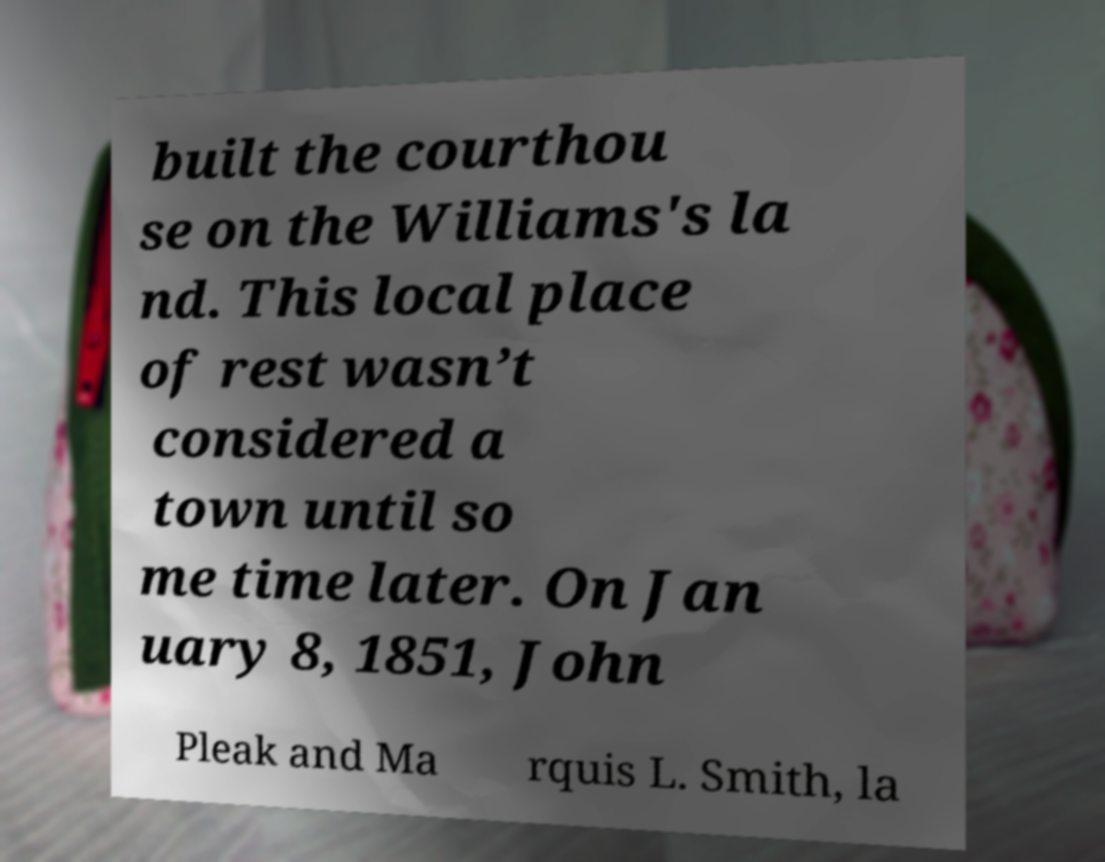Could you extract and type out the text from this image? built the courthou se on the Williams's la nd. This local place of rest wasn’t considered a town until so me time later. On Jan uary 8, 1851, John Pleak and Ma rquis L. Smith, la 